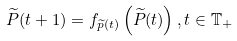Convert formula to latex. <formula><loc_0><loc_0><loc_500><loc_500>\widetilde { P } ( t + 1 ) = f _ { \widetilde { p } ( t ) } \left ( \widetilde { P } ( t ) \right ) , t \in \mathbb { T } _ { + }</formula> 